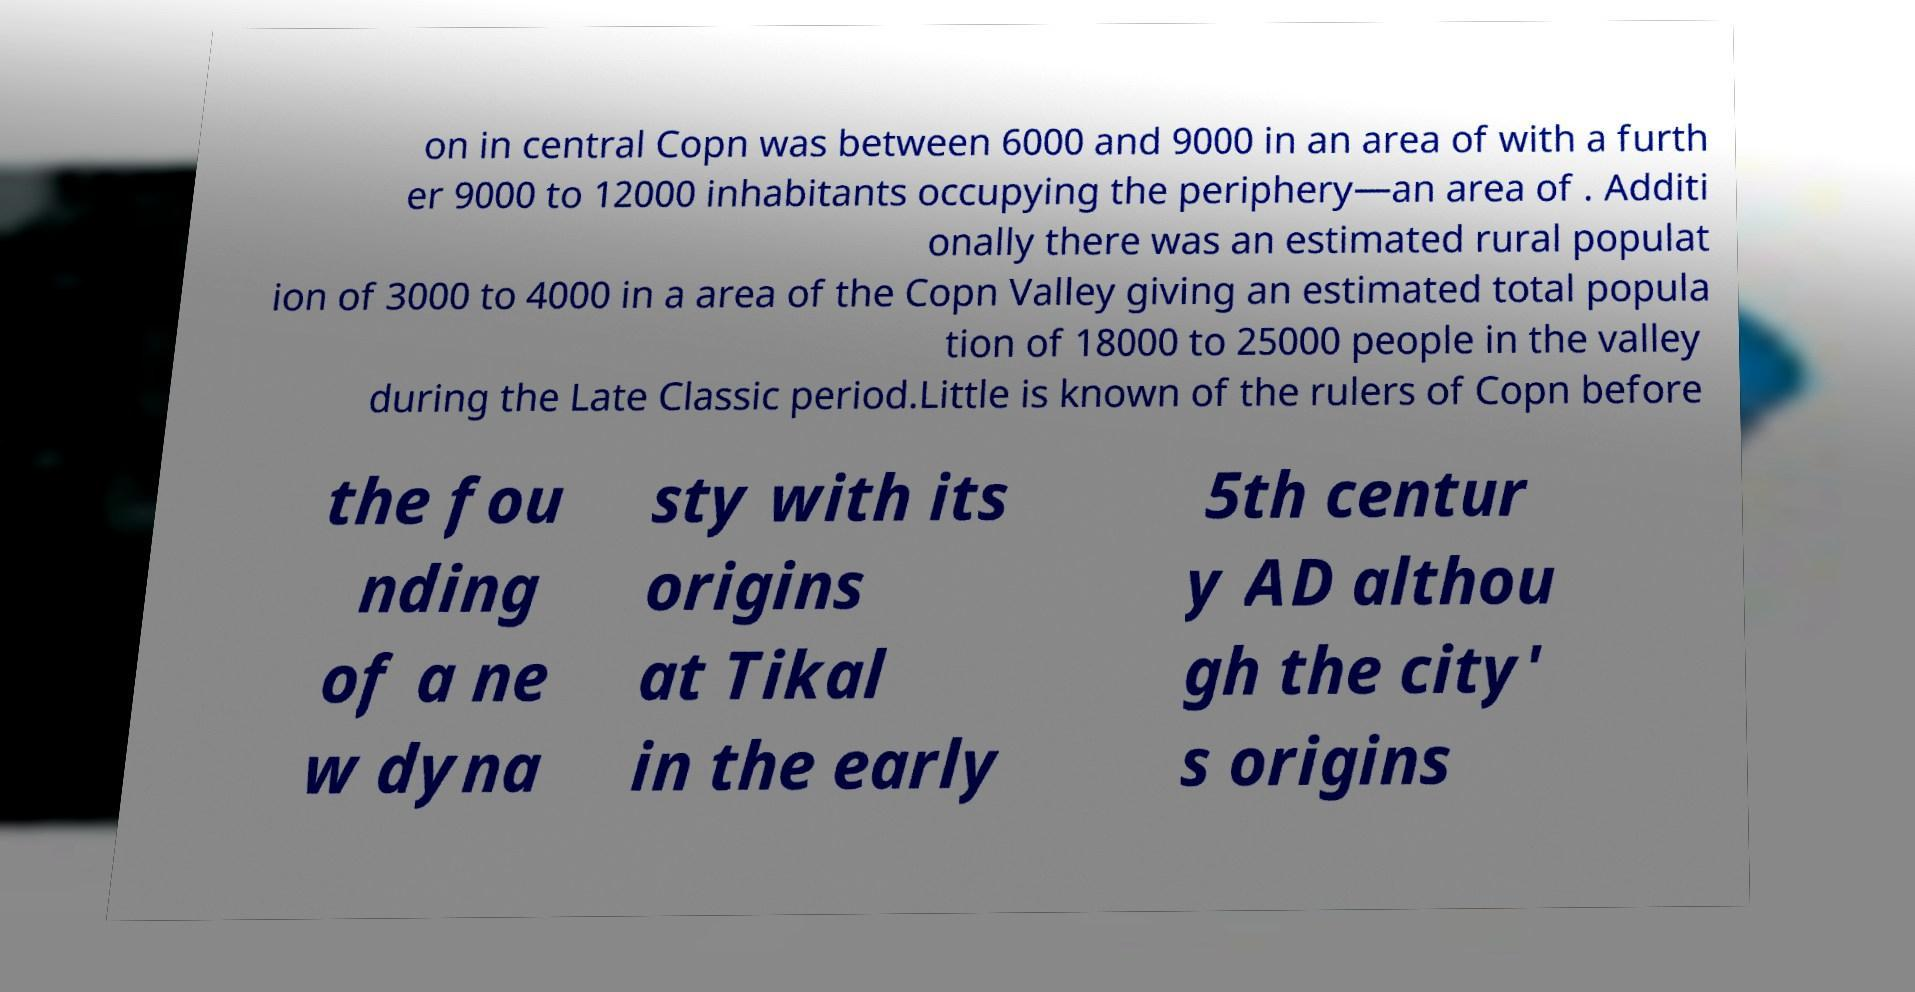I need the written content from this picture converted into text. Can you do that? on in central Copn was between 6000 and 9000 in an area of with a furth er 9000 to 12000 inhabitants occupying the periphery—an area of . Additi onally there was an estimated rural populat ion of 3000 to 4000 in a area of the Copn Valley giving an estimated total popula tion of 18000 to 25000 people in the valley during the Late Classic period.Little is known of the rulers of Copn before the fou nding of a ne w dyna sty with its origins at Tikal in the early 5th centur y AD althou gh the city' s origins 